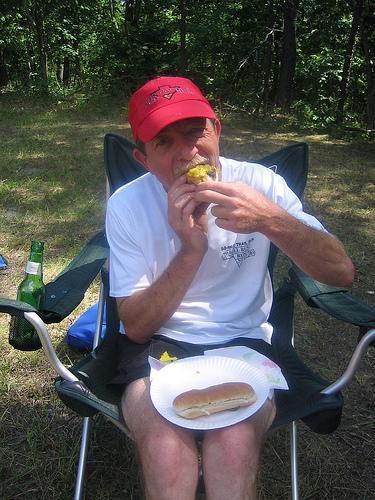How many people are there?
Give a very brief answer. 1. How many hotdogs does the man have?
Give a very brief answer. 2. 